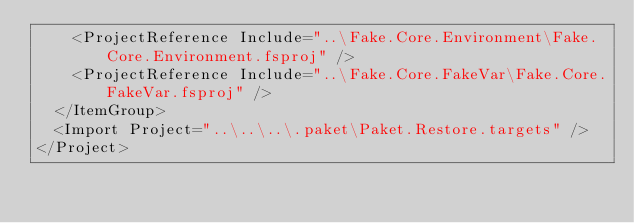<code> <loc_0><loc_0><loc_500><loc_500><_XML_>    <ProjectReference Include="..\Fake.Core.Environment\Fake.Core.Environment.fsproj" />
    <ProjectReference Include="..\Fake.Core.FakeVar\Fake.Core.FakeVar.fsproj" />
  </ItemGroup>
  <Import Project="..\..\..\.paket\Paket.Restore.targets" />
</Project>
</code> 